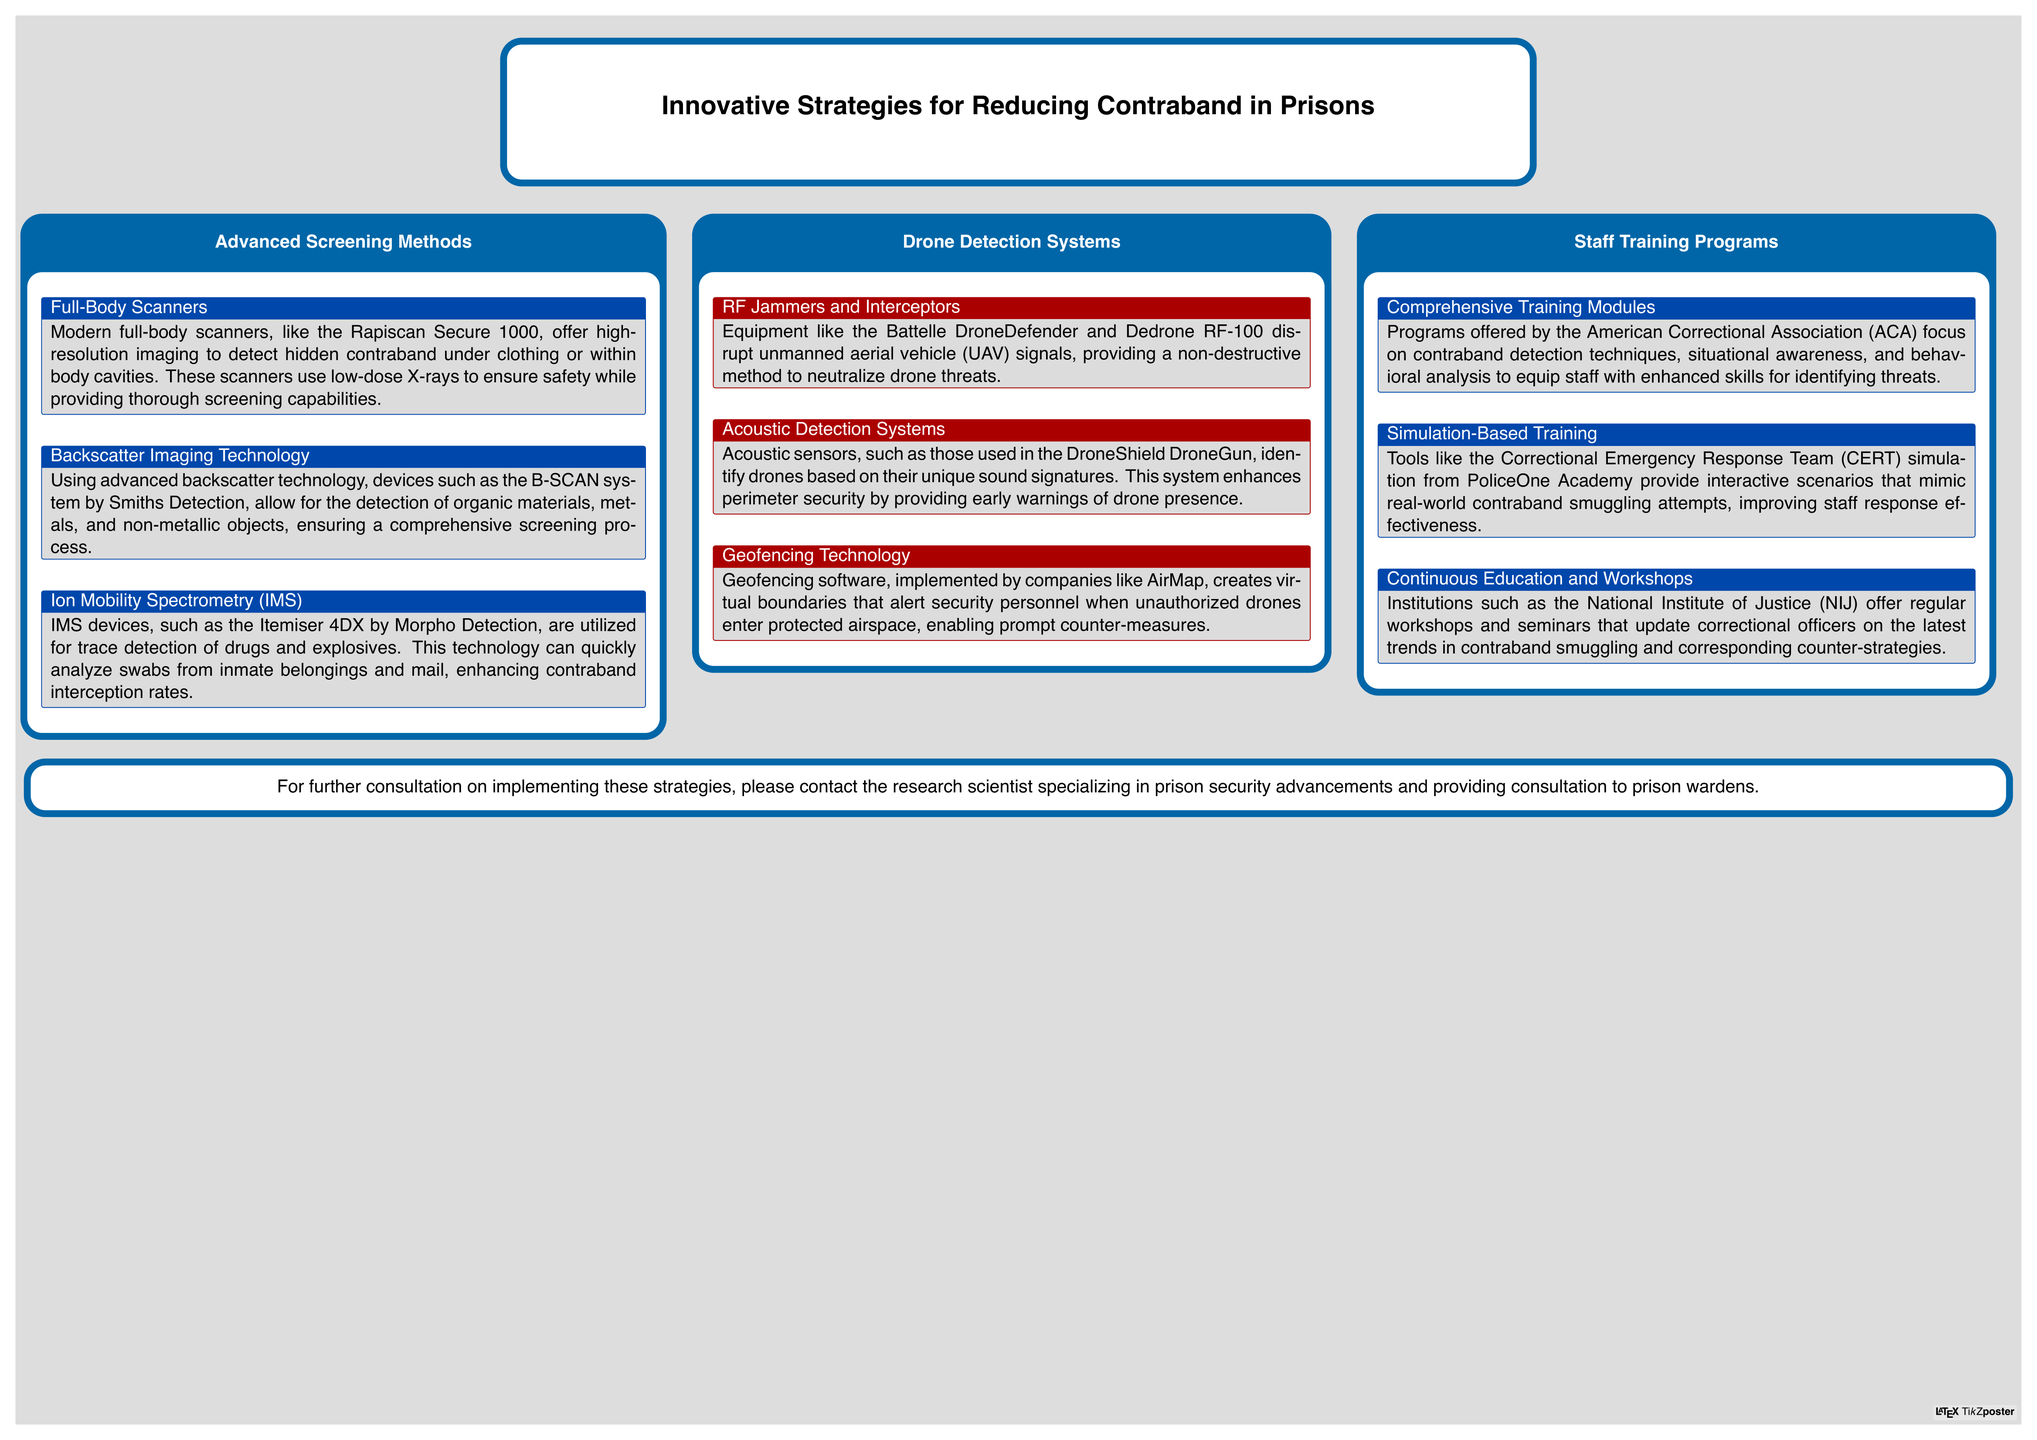What is the name of the full-body scanner mentioned? The name of the full-body scanner is the Rapiscan Secure 1000, as noted in the section on Advanced Screening Methods.
Answer: Rapiscan Secure 1000 What technology does the B-SCAN system utilize? The B-SCAN system uses advanced backscatter technology for detection, as stated in the Advanced Screening Methods section.
Answer: Backscatter technology Which device is used for trace detection of drugs and explosives? The Itemiser 4DX by Morpho Detection is mentioned for trace detection in the document.
Answer: Itemiser 4DX What are RF Jammers and Interceptors used for? The document states that RF Jammers and Interceptors disrupt UAV signals, categorizing them under Drone Detection Systems.
Answer: Disrupt UAV signals What training program focuses on contraband detection techniques? The comprehensive training modules offered by the American Correctional Association (ACA) focus on contraband detection techniques.
Answer: American Correctional Association (ACA) What tool provides interactive scenarios for staff training? The Correctional Emergency Response Team (CERT) simulation from PoliceOne Academy offers interactive scenarios for training.
Answer: CERT simulation Which organization offers workshops to update correctional officers? The National Institute of Justice (NIJ) provides regular workshops for ongoing education, as highlighted in the Staff Training Programs section.
Answer: National Institute of Justice (NIJ) What is the purpose of geofencing technology? Geofencing technology creates virtual boundaries to alert security personnel, as explained in the Drone Detection Systems section.
Answer: Alert security personnel How does acoustic detection enhance perimeter security? Acoustic sensors identify drones based on sound signatures, improving perimeter security through early warnings, according to the document.
Answer: Early warnings 